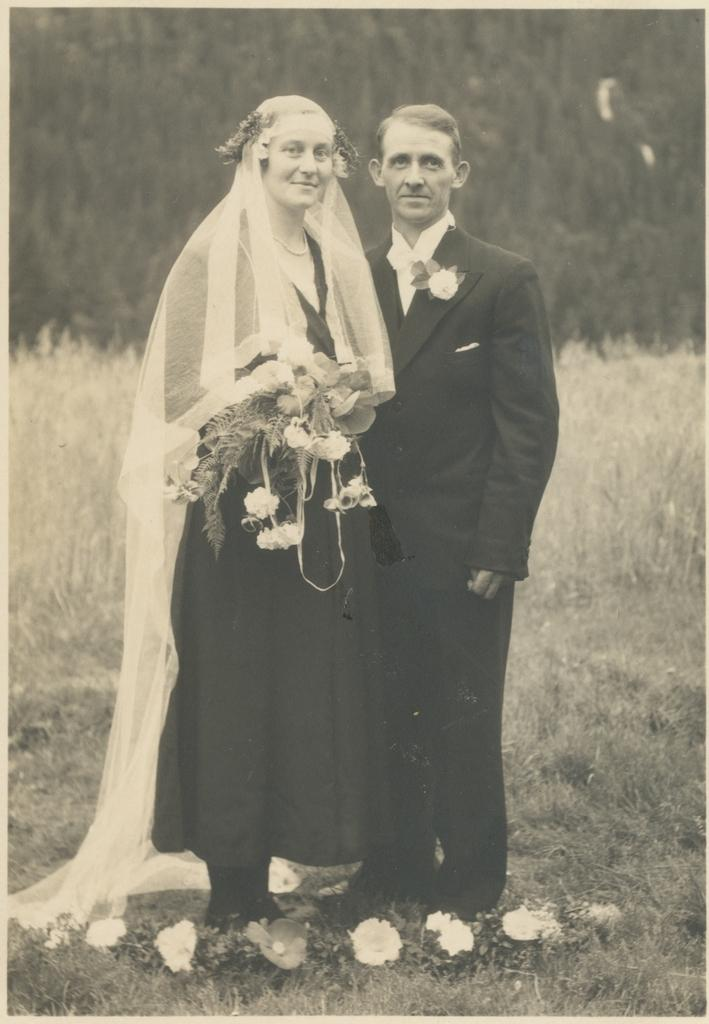How many people are in the image? There is a man and a woman in the image. What is the woman holding in the image? The woman is holding flowers. What type of vegetation can be seen on the ground in the image? There is grass on the ground in the image. What can be seen in the background of the image? There are trees visible in the image. What is the woman wearing on her head? The woman has a cloth on her head. What type of breakfast is being served on the tray in the image? There is no tray or breakfast present in the image. What type of animal can be seen interacting with the woman in the image? There is no animal present in the image; it only features a man and a woman. 